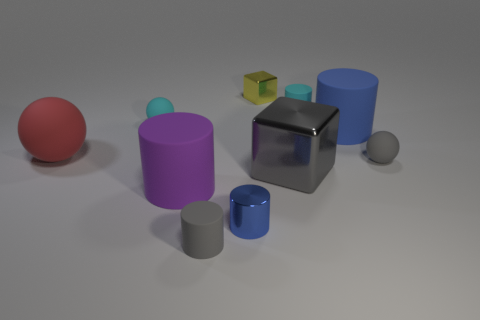The cylinder on the left side of the rubber cylinder that is in front of the blue cylinder to the left of the tiny cube is made of what material?
Provide a succinct answer. Rubber. Is the cyan ball made of the same material as the tiny gray object in front of the gray metallic block?
Your answer should be very brief. Yes. There is a small cyan thing that is the same shape as the large purple object; what is it made of?
Give a very brief answer. Rubber. Is there any other thing that is the same material as the big blue cylinder?
Provide a short and direct response. Yes. Is the number of tiny cylinders behind the blue metal object greater than the number of small objects that are behind the gray shiny block?
Offer a terse response. No. There is a big blue object that is made of the same material as the large red thing; what shape is it?
Your answer should be compact. Cylinder. How many other objects are the same shape as the large purple object?
Your response must be concise. 4. What is the shape of the small gray object that is behind the large purple matte cylinder?
Give a very brief answer. Sphere. The large cube is what color?
Offer a terse response. Gray. What number of other objects are the same size as the purple rubber object?
Provide a short and direct response. 3. 